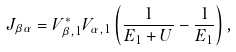Convert formula to latex. <formula><loc_0><loc_0><loc_500><loc_500>J _ { \beta \alpha } = V _ { \beta , 1 } ^ { * } V _ { \alpha , 1 } \left ( \frac { 1 } { E _ { 1 } + U } - \frac { 1 } { E _ { 1 } } \right ) ,</formula> 